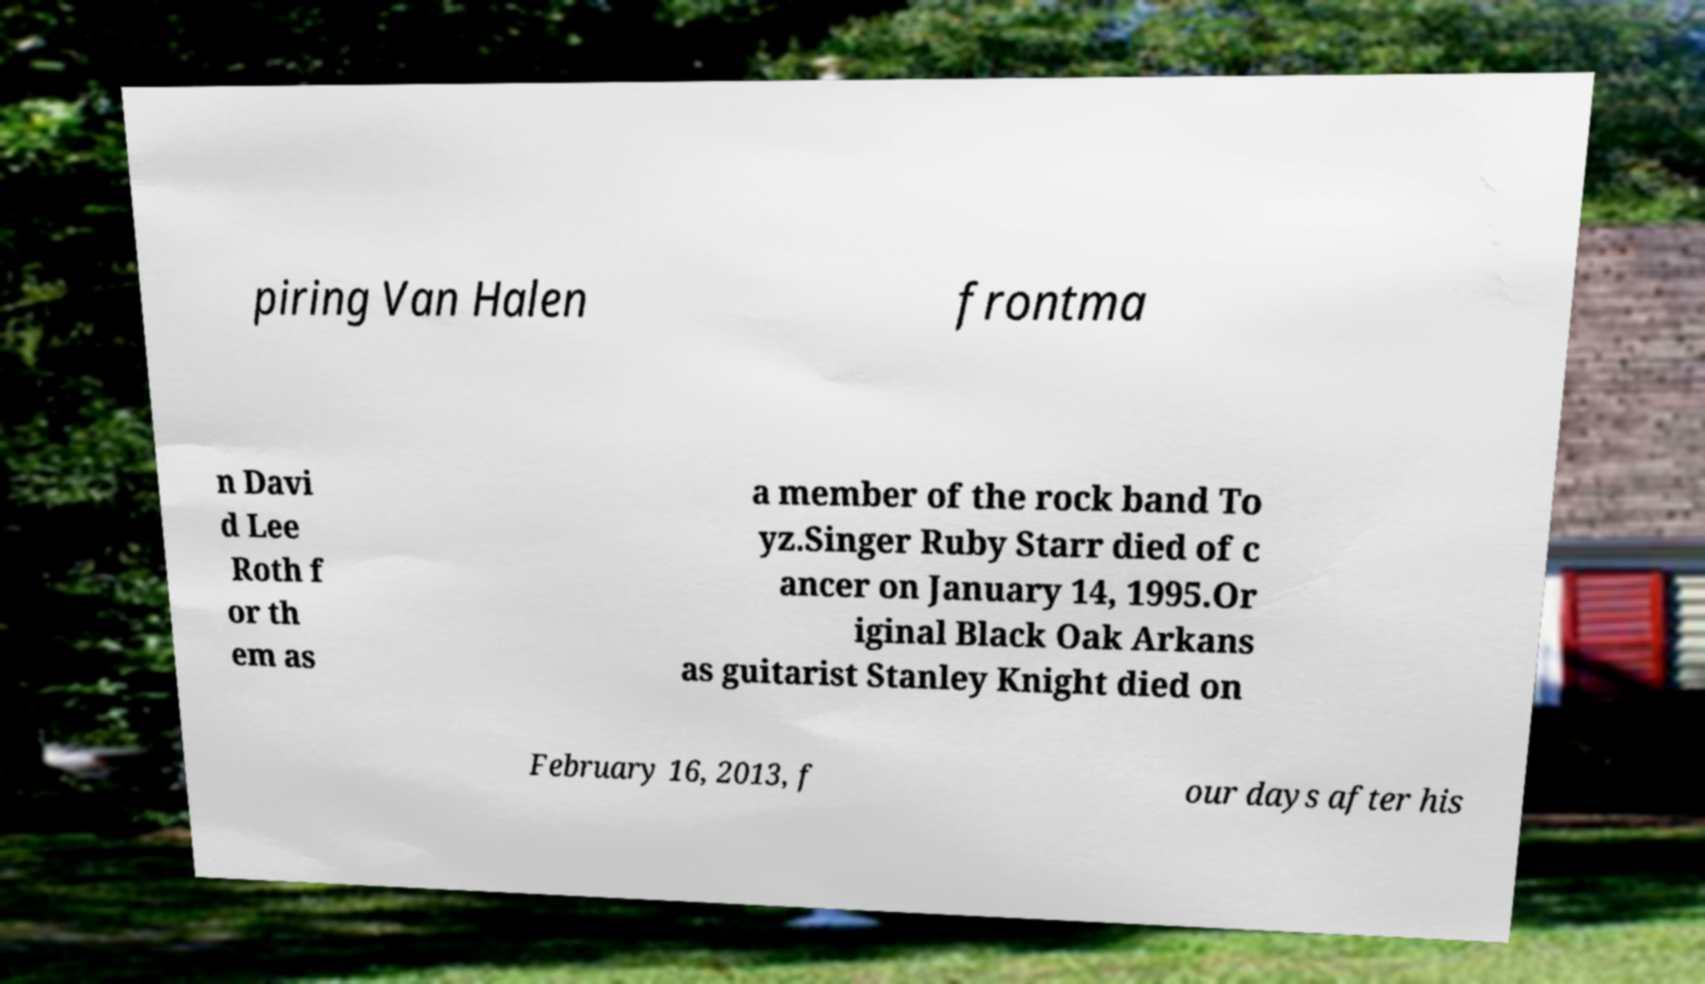Can you accurately transcribe the text from the provided image for me? piring Van Halen frontma n Davi d Lee Roth f or th em as a member of the rock band To yz.Singer Ruby Starr died of c ancer on January 14, 1995.Or iginal Black Oak Arkans as guitarist Stanley Knight died on February 16, 2013, f our days after his 